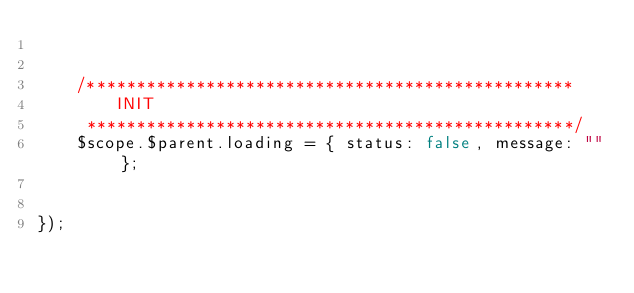Convert code to text. <code><loc_0><loc_0><loc_500><loc_500><_JavaScript_>

    /*************************************************
        INIT
     *************************************************/
    $scope.$parent.loading = { status: false, message: "" };


});
</code> 